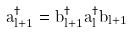Convert formula to latex. <formula><loc_0><loc_0><loc_500><loc_500>a _ { l + 1 } ^ { \dag } = b _ { l + 1 } ^ { \dag } a _ { l } ^ { \dag } b _ { l + 1 }</formula> 